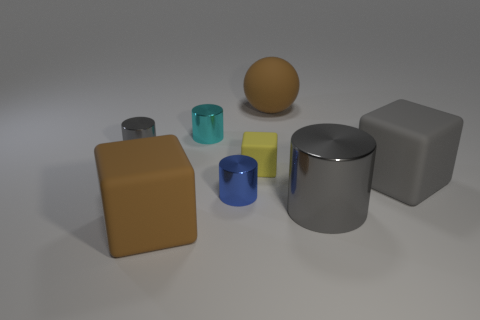Subtract all green cylinders. Subtract all red blocks. How many cylinders are left? 4 Add 2 cyan cylinders. How many objects exist? 10 Subtract all balls. How many objects are left? 7 Subtract 0 cyan balls. How many objects are left? 8 Subtract all balls. Subtract all large gray objects. How many objects are left? 5 Add 8 big matte spheres. How many big matte spheres are left? 9 Add 1 big shiny things. How many big shiny things exist? 2 